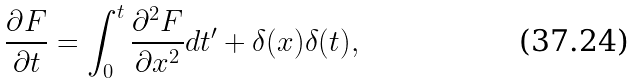<formula> <loc_0><loc_0><loc_500><loc_500>\frac { \partial F } { \partial t } = \int _ { 0 } ^ { t } \frac { \partial ^ { 2 } F } { \partial x ^ { 2 } } d t ^ { \prime } + \delta ( x ) \delta ( t ) ,</formula> 